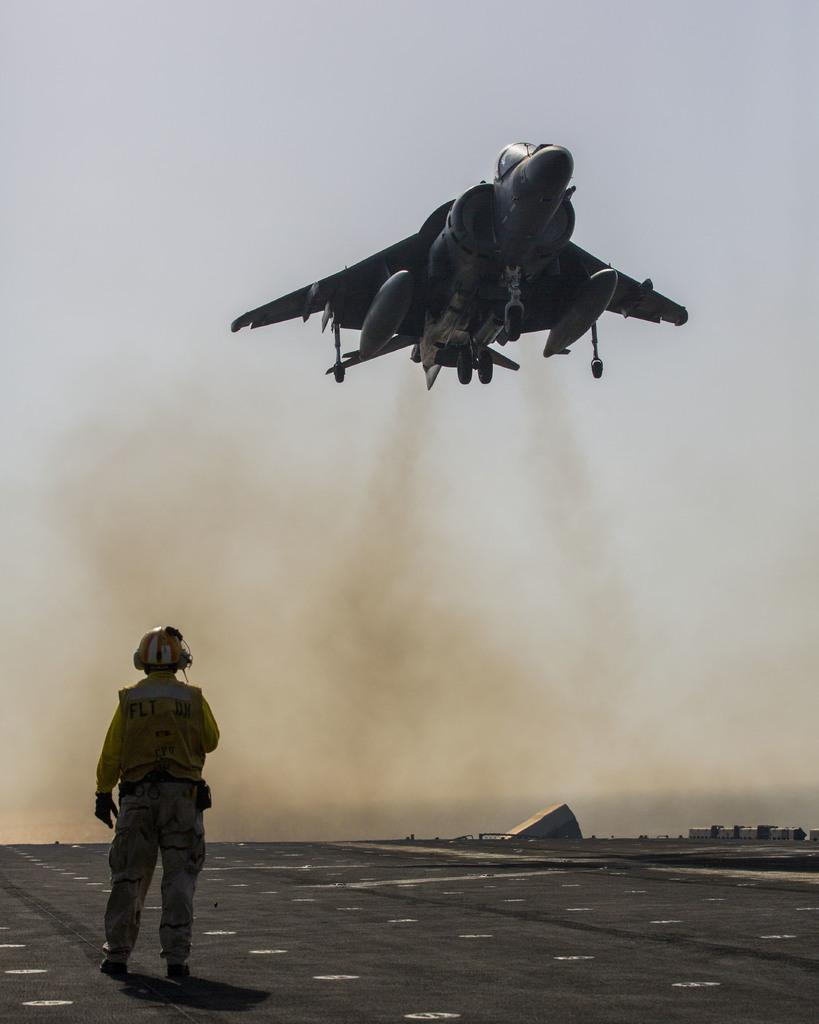What is the man in the image doing? The man is walking on the road. What is the man wearing on his head? The man is wearing a helmet. What can be seen in the sky in the image? There is an airplane in the air. What is the source of the smoke visible in the image? The source of the smoke is not specified in the image. What is visible in the background of the image? The sky is visible in the image. What year is depicted in the image? The image does not depict a specific year; it is a snapshot of a moment in time. 